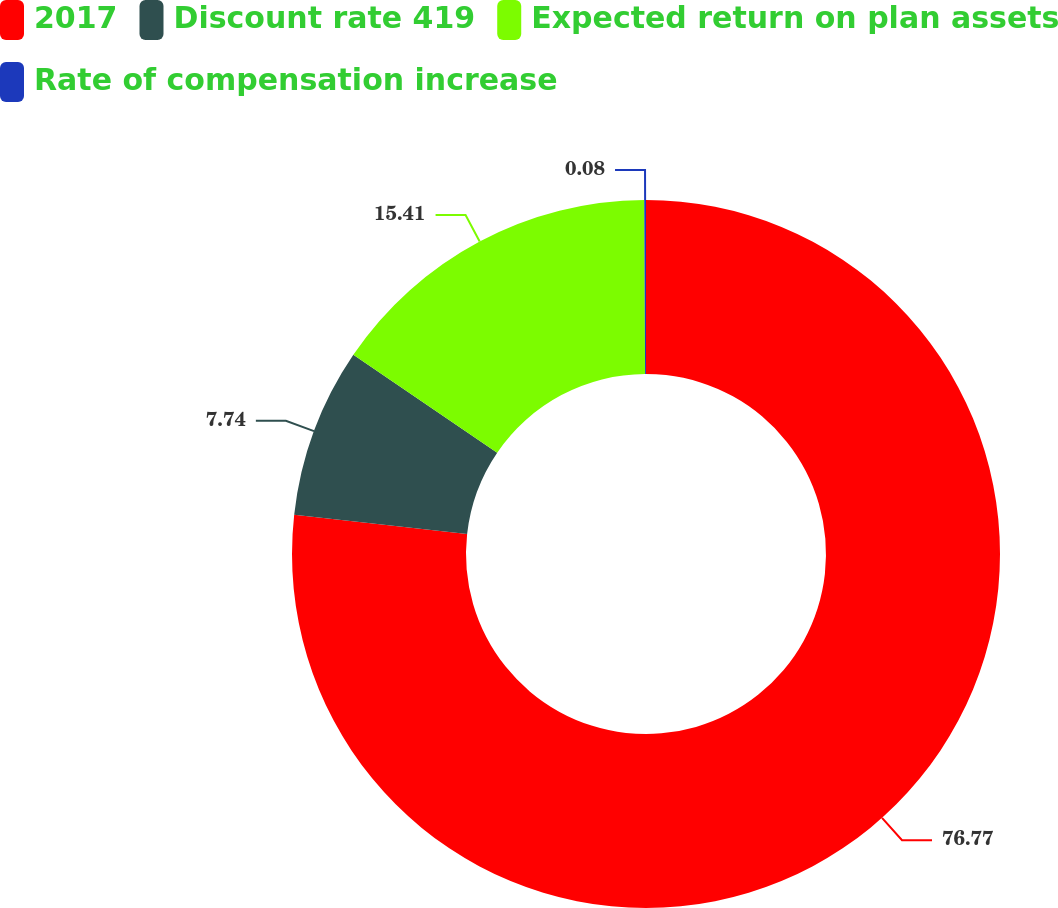Convert chart to OTSL. <chart><loc_0><loc_0><loc_500><loc_500><pie_chart><fcel>2017<fcel>Discount rate 419<fcel>Expected return on plan assets<fcel>Rate of compensation increase<nl><fcel>76.77%<fcel>7.74%<fcel>15.41%<fcel>0.08%<nl></chart> 